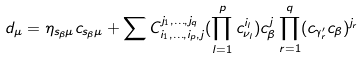<formula> <loc_0><loc_0><loc_500><loc_500>d _ { \mu } = \eta _ { s _ { \beta } \mu } c _ { s _ { \beta } \mu } + \sum C _ { i _ { 1 } , \dots , i _ { p } , j } ^ { j _ { 1 } , \dots , j _ { q } } ( \prod _ { l = 1 } ^ { p } c _ { \nu _ { l } } ^ { i _ { l } } ) c _ { \beta } ^ { j } \prod _ { r = 1 } ^ { q } ( c _ { \gamma ^ { \prime } _ { r } } c _ { \beta } ) ^ { j _ { r } }</formula> 